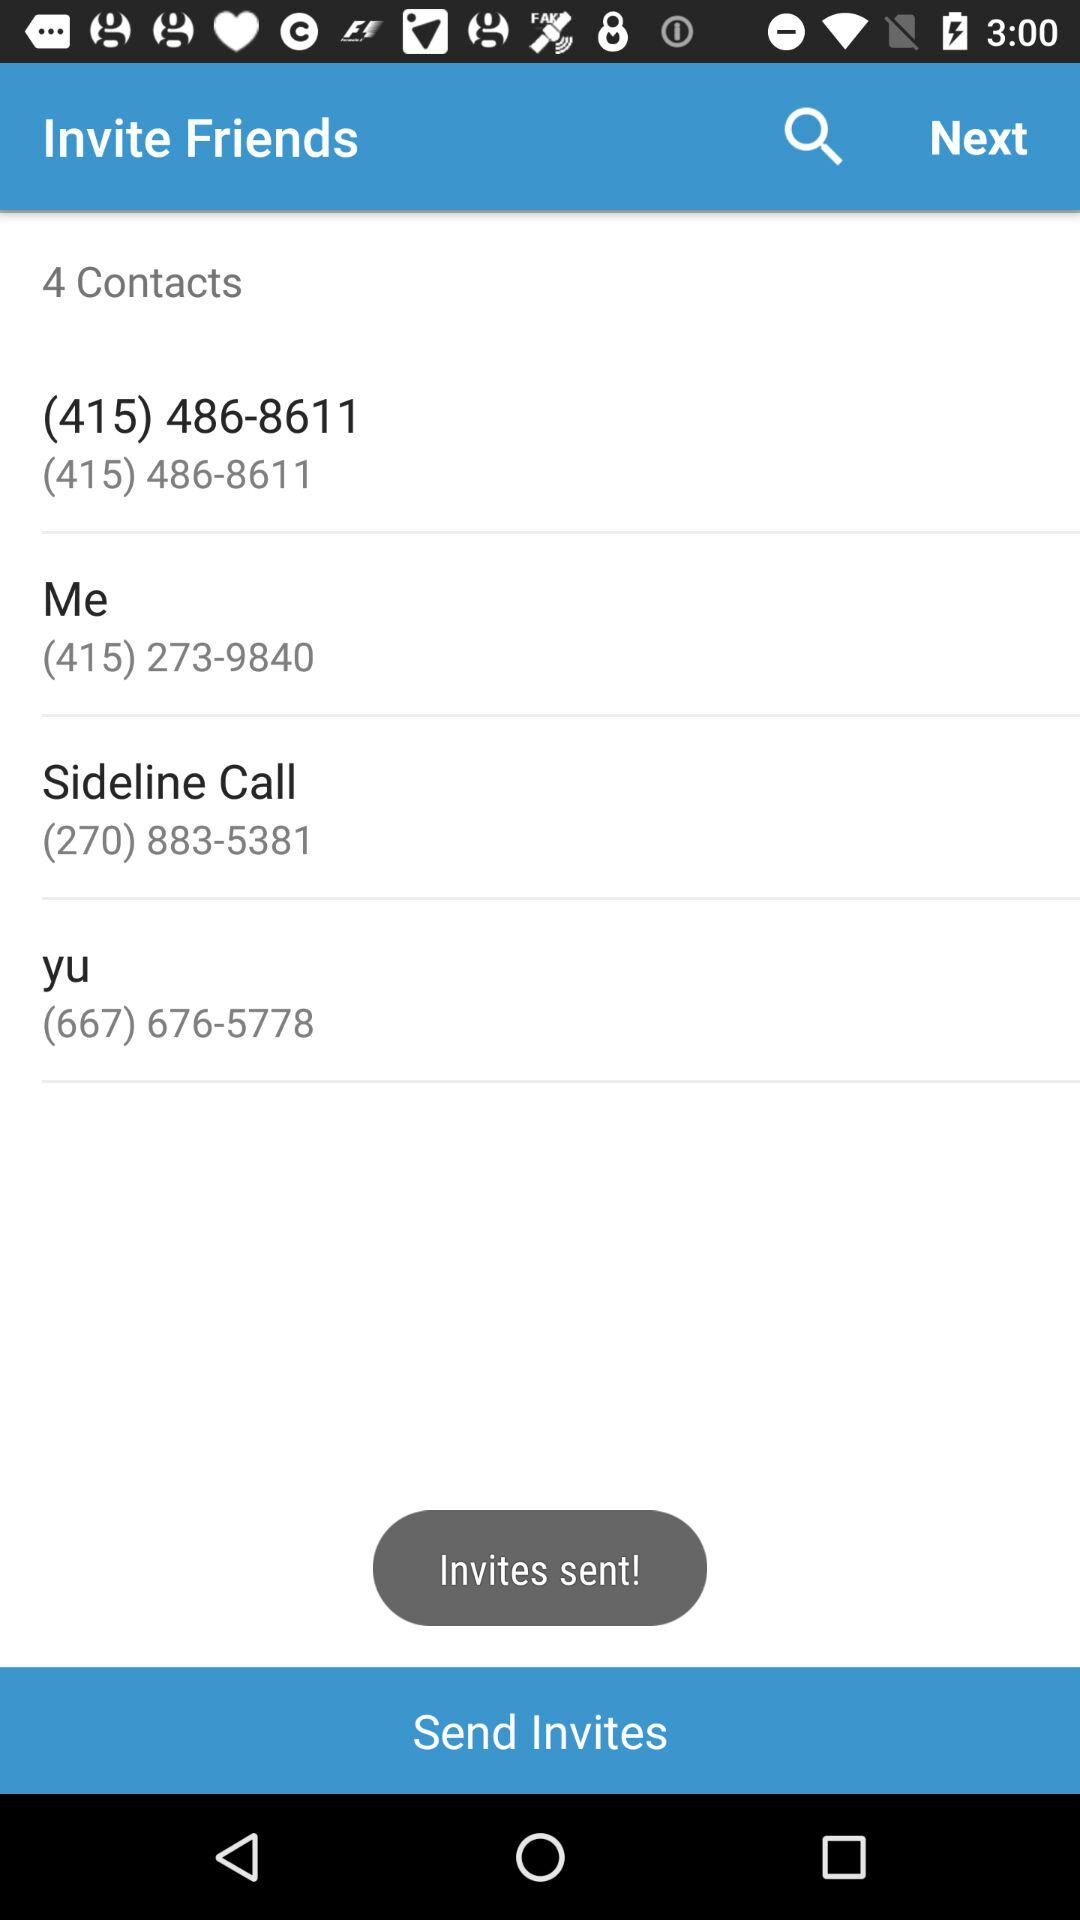How many contacts have been invited?
Answer the question using a single word or phrase. 4 